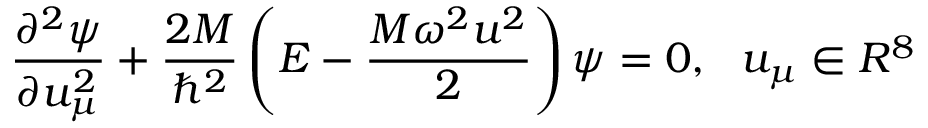<formula> <loc_0><loc_0><loc_500><loc_500>\frac { { \partial } ^ { 2 } \psi } { \partial u _ { \mu } ^ { 2 } } + \frac { 2 M } { \hbar { ^ } { 2 } } \left ( E - \frac { M \omega ^ { 2 } u ^ { 2 } } { 2 } \right ) \psi = 0 , \, u _ { \mu } \in R ^ { 8 }</formula> 